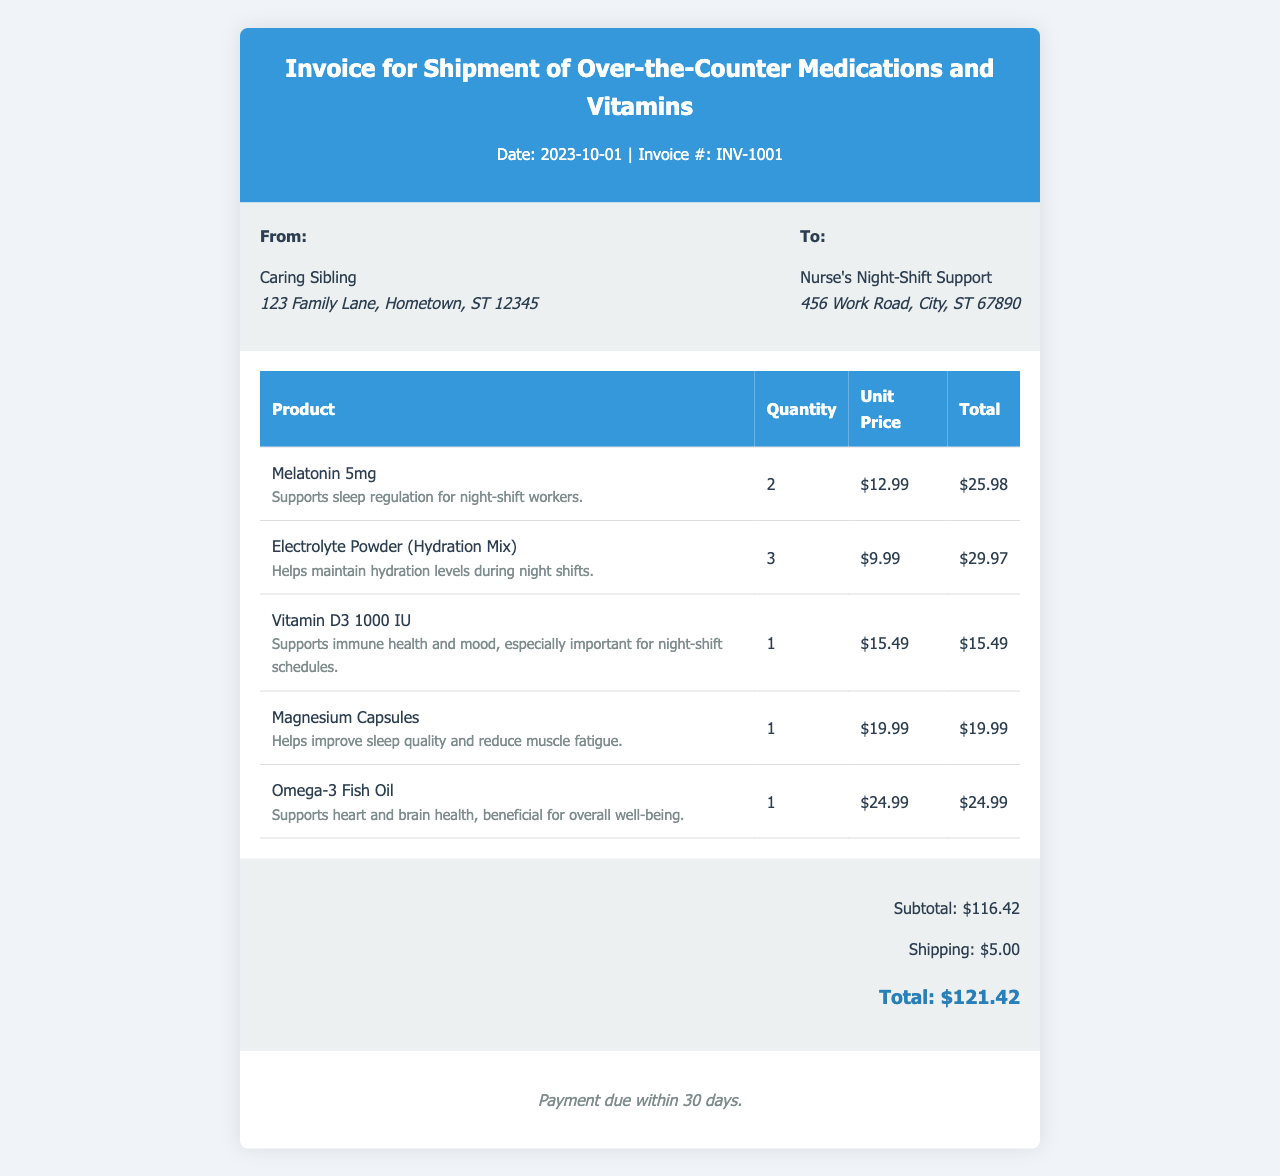What is the invoice number? The invoice number appears at the top of the document as INV-1001.
Answer: INV-1001 What is the subtotal amount? The subtotal is listed in the totals section of the invoice, which is $116.42.
Answer: $116.42 How many Melatonin 5mg products were ordered? In the itemized list, the quantity of Melatonin 5mg is shown as 2.
Answer: 2 What is the shipping cost? The shipping cost is indicated in the totals section and is $5.00.
Answer: $5.00 Who is the invoice addressed to? The invoice is addressed to "Nurse's Night-Shift Support," as shown in the document.
Answer: Nurse's Night-Shift Support What is the total amount due? The total amount due is calculated at the end of the invoice as $121.42.
Answer: $121.42 Which item supports hydration during night shifts? The item mentioned for hydration support is "Electrolyte Powder (Hydration Mix)."
Answer: Electrolyte Powder (Hydration Mix) What is the due date for payment? The terms state payment is due within 30 days, as noted at the bottom of the invoice.
Answer: 30 days How many different products are listed? The document lists five different products in the itemized sections.
Answer: 5 